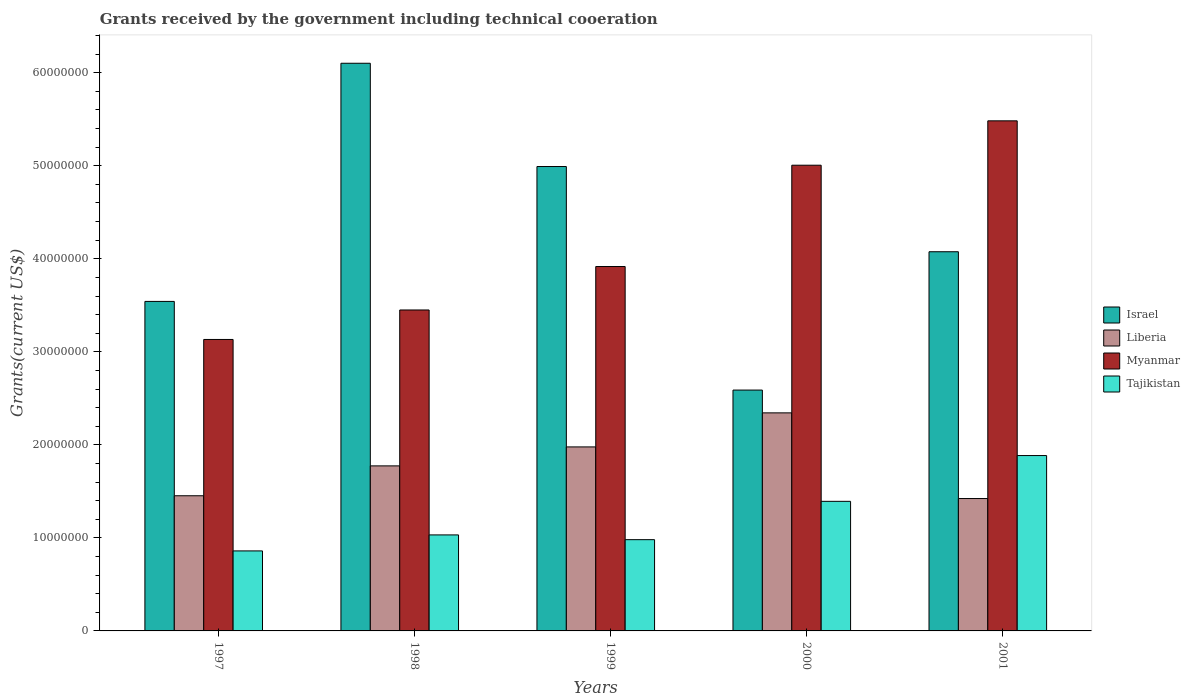How many different coloured bars are there?
Ensure brevity in your answer.  4. Are the number of bars per tick equal to the number of legend labels?
Make the answer very short. Yes. How many bars are there on the 5th tick from the left?
Offer a terse response. 4. How many bars are there on the 5th tick from the right?
Give a very brief answer. 4. In how many cases, is the number of bars for a given year not equal to the number of legend labels?
Your response must be concise. 0. What is the total grants received by the government in Israel in 1998?
Offer a very short reply. 6.10e+07. Across all years, what is the maximum total grants received by the government in Israel?
Make the answer very short. 6.10e+07. Across all years, what is the minimum total grants received by the government in Tajikistan?
Provide a short and direct response. 8.60e+06. In which year was the total grants received by the government in Israel minimum?
Your response must be concise. 2000. What is the total total grants received by the government in Myanmar in the graph?
Give a very brief answer. 2.10e+08. What is the difference between the total grants received by the government in Israel in 1997 and that in 1998?
Offer a terse response. -2.56e+07. What is the difference between the total grants received by the government in Myanmar in 1997 and the total grants received by the government in Tajikistan in 2001?
Your answer should be very brief. 1.25e+07. What is the average total grants received by the government in Israel per year?
Ensure brevity in your answer.  4.26e+07. In the year 1997, what is the difference between the total grants received by the government in Tajikistan and total grants received by the government in Myanmar?
Your answer should be very brief. -2.27e+07. In how many years, is the total grants received by the government in Myanmar greater than 26000000 US$?
Offer a terse response. 5. What is the ratio of the total grants received by the government in Myanmar in 1997 to that in 2001?
Provide a succinct answer. 0.57. Is the total grants received by the government in Myanmar in 1997 less than that in 1999?
Keep it short and to the point. Yes. Is the difference between the total grants received by the government in Tajikistan in 1999 and 2001 greater than the difference between the total grants received by the government in Myanmar in 1999 and 2001?
Offer a very short reply. Yes. What is the difference between the highest and the second highest total grants received by the government in Myanmar?
Provide a short and direct response. 4.77e+06. What is the difference between the highest and the lowest total grants received by the government in Liberia?
Provide a short and direct response. 9.21e+06. Is it the case that in every year, the sum of the total grants received by the government in Myanmar and total grants received by the government in Liberia is greater than the sum of total grants received by the government in Tajikistan and total grants received by the government in Israel?
Keep it short and to the point. No. What does the 1st bar from the left in 1997 represents?
Provide a short and direct response. Israel. What does the 2nd bar from the right in 1999 represents?
Offer a terse response. Myanmar. Is it the case that in every year, the sum of the total grants received by the government in Tajikistan and total grants received by the government in Myanmar is greater than the total grants received by the government in Israel?
Ensure brevity in your answer.  No. How many bars are there?
Make the answer very short. 20. Are all the bars in the graph horizontal?
Provide a short and direct response. No. How many years are there in the graph?
Offer a very short reply. 5. What is the difference between two consecutive major ticks on the Y-axis?
Give a very brief answer. 1.00e+07. Does the graph contain any zero values?
Offer a very short reply. No. Where does the legend appear in the graph?
Your answer should be very brief. Center right. How are the legend labels stacked?
Offer a very short reply. Vertical. What is the title of the graph?
Offer a terse response. Grants received by the government including technical cooeration. What is the label or title of the Y-axis?
Your answer should be compact. Grants(current US$). What is the Grants(current US$) of Israel in 1997?
Ensure brevity in your answer.  3.54e+07. What is the Grants(current US$) in Liberia in 1997?
Provide a succinct answer. 1.45e+07. What is the Grants(current US$) in Myanmar in 1997?
Provide a succinct answer. 3.13e+07. What is the Grants(current US$) in Tajikistan in 1997?
Give a very brief answer. 8.60e+06. What is the Grants(current US$) in Israel in 1998?
Offer a terse response. 6.10e+07. What is the Grants(current US$) in Liberia in 1998?
Give a very brief answer. 1.77e+07. What is the Grants(current US$) in Myanmar in 1998?
Ensure brevity in your answer.  3.45e+07. What is the Grants(current US$) of Tajikistan in 1998?
Your answer should be compact. 1.03e+07. What is the Grants(current US$) of Israel in 1999?
Your answer should be very brief. 4.99e+07. What is the Grants(current US$) in Liberia in 1999?
Your answer should be compact. 1.98e+07. What is the Grants(current US$) of Myanmar in 1999?
Offer a very short reply. 3.92e+07. What is the Grants(current US$) in Tajikistan in 1999?
Provide a succinct answer. 9.81e+06. What is the Grants(current US$) in Israel in 2000?
Provide a short and direct response. 2.59e+07. What is the Grants(current US$) of Liberia in 2000?
Offer a terse response. 2.34e+07. What is the Grants(current US$) of Myanmar in 2000?
Ensure brevity in your answer.  5.01e+07. What is the Grants(current US$) in Tajikistan in 2000?
Your answer should be very brief. 1.39e+07. What is the Grants(current US$) of Israel in 2001?
Keep it short and to the point. 4.08e+07. What is the Grants(current US$) of Liberia in 2001?
Your response must be concise. 1.42e+07. What is the Grants(current US$) in Myanmar in 2001?
Make the answer very short. 5.48e+07. What is the Grants(current US$) in Tajikistan in 2001?
Make the answer very short. 1.88e+07. Across all years, what is the maximum Grants(current US$) of Israel?
Your answer should be very brief. 6.10e+07. Across all years, what is the maximum Grants(current US$) in Liberia?
Offer a very short reply. 2.34e+07. Across all years, what is the maximum Grants(current US$) in Myanmar?
Make the answer very short. 5.48e+07. Across all years, what is the maximum Grants(current US$) in Tajikistan?
Offer a terse response. 1.88e+07. Across all years, what is the minimum Grants(current US$) of Israel?
Give a very brief answer. 2.59e+07. Across all years, what is the minimum Grants(current US$) of Liberia?
Offer a terse response. 1.42e+07. Across all years, what is the minimum Grants(current US$) in Myanmar?
Give a very brief answer. 3.13e+07. Across all years, what is the minimum Grants(current US$) of Tajikistan?
Provide a succinct answer. 8.60e+06. What is the total Grants(current US$) of Israel in the graph?
Keep it short and to the point. 2.13e+08. What is the total Grants(current US$) in Liberia in the graph?
Offer a terse response. 8.97e+07. What is the total Grants(current US$) of Myanmar in the graph?
Your answer should be very brief. 2.10e+08. What is the total Grants(current US$) of Tajikistan in the graph?
Provide a succinct answer. 6.15e+07. What is the difference between the Grants(current US$) in Israel in 1997 and that in 1998?
Offer a very short reply. -2.56e+07. What is the difference between the Grants(current US$) in Liberia in 1997 and that in 1998?
Keep it short and to the point. -3.21e+06. What is the difference between the Grants(current US$) in Myanmar in 1997 and that in 1998?
Make the answer very short. -3.17e+06. What is the difference between the Grants(current US$) in Tajikistan in 1997 and that in 1998?
Offer a very short reply. -1.72e+06. What is the difference between the Grants(current US$) of Israel in 1997 and that in 1999?
Your answer should be compact. -1.45e+07. What is the difference between the Grants(current US$) in Liberia in 1997 and that in 1999?
Your answer should be compact. -5.25e+06. What is the difference between the Grants(current US$) of Myanmar in 1997 and that in 1999?
Your answer should be compact. -7.84e+06. What is the difference between the Grants(current US$) of Tajikistan in 1997 and that in 1999?
Offer a terse response. -1.21e+06. What is the difference between the Grants(current US$) in Israel in 1997 and that in 2000?
Your response must be concise. 9.53e+06. What is the difference between the Grants(current US$) of Liberia in 1997 and that in 2000?
Ensure brevity in your answer.  -8.91e+06. What is the difference between the Grants(current US$) of Myanmar in 1997 and that in 2000?
Provide a short and direct response. -1.87e+07. What is the difference between the Grants(current US$) of Tajikistan in 1997 and that in 2000?
Provide a short and direct response. -5.33e+06. What is the difference between the Grants(current US$) in Israel in 1997 and that in 2001?
Your answer should be very brief. -5.34e+06. What is the difference between the Grants(current US$) in Myanmar in 1997 and that in 2001?
Offer a terse response. -2.35e+07. What is the difference between the Grants(current US$) of Tajikistan in 1997 and that in 2001?
Give a very brief answer. -1.02e+07. What is the difference between the Grants(current US$) of Israel in 1998 and that in 1999?
Provide a short and direct response. 1.11e+07. What is the difference between the Grants(current US$) in Liberia in 1998 and that in 1999?
Your answer should be compact. -2.04e+06. What is the difference between the Grants(current US$) of Myanmar in 1998 and that in 1999?
Provide a short and direct response. -4.67e+06. What is the difference between the Grants(current US$) in Tajikistan in 1998 and that in 1999?
Give a very brief answer. 5.10e+05. What is the difference between the Grants(current US$) of Israel in 1998 and that in 2000?
Give a very brief answer. 3.51e+07. What is the difference between the Grants(current US$) in Liberia in 1998 and that in 2000?
Provide a succinct answer. -5.70e+06. What is the difference between the Grants(current US$) of Myanmar in 1998 and that in 2000?
Give a very brief answer. -1.56e+07. What is the difference between the Grants(current US$) of Tajikistan in 1998 and that in 2000?
Ensure brevity in your answer.  -3.61e+06. What is the difference between the Grants(current US$) of Israel in 1998 and that in 2001?
Provide a short and direct response. 2.03e+07. What is the difference between the Grants(current US$) in Liberia in 1998 and that in 2001?
Provide a short and direct response. 3.51e+06. What is the difference between the Grants(current US$) of Myanmar in 1998 and that in 2001?
Keep it short and to the point. -2.03e+07. What is the difference between the Grants(current US$) in Tajikistan in 1998 and that in 2001?
Your answer should be compact. -8.53e+06. What is the difference between the Grants(current US$) in Israel in 1999 and that in 2000?
Keep it short and to the point. 2.40e+07. What is the difference between the Grants(current US$) of Liberia in 1999 and that in 2000?
Your answer should be compact. -3.66e+06. What is the difference between the Grants(current US$) of Myanmar in 1999 and that in 2000?
Keep it short and to the point. -1.09e+07. What is the difference between the Grants(current US$) of Tajikistan in 1999 and that in 2000?
Ensure brevity in your answer.  -4.12e+06. What is the difference between the Grants(current US$) of Israel in 1999 and that in 2001?
Provide a short and direct response. 9.16e+06. What is the difference between the Grants(current US$) in Liberia in 1999 and that in 2001?
Offer a very short reply. 5.55e+06. What is the difference between the Grants(current US$) of Myanmar in 1999 and that in 2001?
Offer a terse response. -1.57e+07. What is the difference between the Grants(current US$) of Tajikistan in 1999 and that in 2001?
Make the answer very short. -9.04e+06. What is the difference between the Grants(current US$) in Israel in 2000 and that in 2001?
Make the answer very short. -1.49e+07. What is the difference between the Grants(current US$) of Liberia in 2000 and that in 2001?
Your response must be concise. 9.21e+06. What is the difference between the Grants(current US$) in Myanmar in 2000 and that in 2001?
Ensure brevity in your answer.  -4.77e+06. What is the difference between the Grants(current US$) of Tajikistan in 2000 and that in 2001?
Give a very brief answer. -4.92e+06. What is the difference between the Grants(current US$) in Israel in 1997 and the Grants(current US$) in Liberia in 1998?
Provide a short and direct response. 1.77e+07. What is the difference between the Grants(current US$) in Israel in 1997 and the Grants(current US$) in Myanmar in 1998?
Give a very brief answer. 9.20e+05. What is the difference between the Grants(current US$) in Israel in 1997 and the Grants(current US$) in Tajikistan in 1998?
Keep it short and to the point. 2.51e+07. What is the difference between the Grants(current US$) in Liberia in 1997 and the Grants(current US$) in Myanmar in 1998?
Your answer should be very brief. -2.00e+07. What is the difference between the Grants(current US$) of Liberia in 1997 and the Grants(current US$) of Tajikistan in 1998?
Give a very brief answer. 4.21e+06. What is the difference between the Grants(current US$) of Myanmar in 1997 and the Grants(current US$) of Tajikistan in 1998?
Provide a succinct answer. 2.10e+07. What is the difference between the Grants(current US$) of Israel in 1997 and the Grants(current US$) of Liberia in 1999?
Provide a succinct answer. 1.56e+07. What is the difference between the Grants(current US$) in Israel in 1997 and the Grants(current US$) in Myanmar in 1999?
Your answer should be very brief. -3.75e+06. What is the difference between the Grants(current US$) of Israel in 1997 and the Grants(current US$) of Tajikistan in 1999?
Give a very brief answer. 2.56e+07. What is the difference between the Grants(current US$) in Liberia in 1997 and the Grants(current US$) in Myanmar in 1999?
Offer a terse response. -2.46e+07. What is the difference between the Grants(current US$) of Liberia in 1997 and the Grants(current US$) of Tajikistan in 1999?
Your response must be concise. 4.72e+06. What is the difference between the Grants(current US$) of Myanmar in 1997 and the Grants(current US$) of Tajikistan in 1999?
Offer a terse response. 2.15e+07. What is the difference between the Grants(current US$) in Israel in 1997 and the Grants(current US$) in Liberia in 2000?
Your response must be concise. 1.20e+07. What is the difference between the Grants(current US$) in Israel in 1997 and the Grants(current US$) in Myanmar in 2000?
Keep it short and to the point. -1.46e+07. What is the difference between the Grants(current US$) in Israel in 1997 and the Grants(current US$) in Tajikistan in 2000?
Offer a very short reply. 2.15e+07. What is the difference between the Grants(current US$) of Liberia in 1997 and the Grants(current US$) of Myanmar in 2000?
Your answer should be very brief. -3.55e+07. What is the difference between the Grants(current US$) in Liberia in 1997 and the Grants(current US$) in Tajikistan in 2000?
Provide a succinct answer. 6.00e+05. What is the difference between the Grants(current US$) of Myanmar in 1997 and the Grants(current US$) of Tajikistan in 2000?
Your answer should be compact. 1.74e+07. What is the difference between the Grants(current US$) in Israel in 1997 and the Grants(current US$) in Liberia in 2001?
Your response must be concise. 2.12e+07. What is the difference between the Grants(current US$) of Israel in 1997 and the Grants(current US$) of Myanmar in 2001?
Ensure brevity in your answer.  -1.94e+07. What is the difference between the Grants(current US$) in Israel in 1997 and the Grants(current US$) in Tajikistan in 2001?
Your response must be concise. 1.66e+07. What is the difference between the Grants(current US$) in Liberia in 1997 and the Grants(current US$) in Myanmar in 2001?
Offer a terse response. -4.03e+07. What is the difference between the Grants(current US$) of Liberia in 1997 and the Grants(current US$) of Tajikistan in 2001?
Ensure brevity in your answer.  -4.32e+06. What is the difference between the Grants(current US$) in Myanmar in 1997 and the Grants(current US$) in Tajikistan in 2001?
Your answer should be very brief. 1.25e+07. What is the difference between the Grants(current US$) of Israel in 1998 and the Grants(current US$) of Liberia in 1999?
Your response must be concise. 4.12e+07. What is the difference between the Grants(current US$) of Israel in 1998 and the Grants(current US$) of Myanmar in 1999?
Give a very brief answer. 2.18e+07. What is the difference between the Grants(current US$) of Israel in 1998 and the Grants(current US$) of Tajikistan in 1999?
Provide a short and direct response. 5.12e+07. What is the difference between the Grants(current US$) of Liberia in 1998 and the Grants(current US$) of Myanmar in 1999?
Provide a short and direct response. -2.14e+07. What is the difference between the Grants(current US$) of Liberia in 1998 and the Grants(current US$) of Tajikistan in 1999?
Your answer should be very brief. 7.93e+06. What is the difference between the Grants(current US$) of Myanmar in 1998 and the Grants(current US$) of Tajikistan in 1999?
Offer a terse response. 2.47e+07. What is the difference between the Grants(current US$) of Israel in 1998 and the Grants(current US$) of Liberia in 2000?
Provide a succinct answer. 3.76e+07. What is the difference between the Grants(current US$) in Israel in 1998 and the Grants(current US$) in Myanmar in 2000?
Your answer should be very brief. 1.10e+07. What is the difference between the Grants(current US$) of Israel in 1998 and the Grants(current US$) of Tajikistan in 2000?
Your answer should be very brief. 4.71e+07. What is the difference between the Grants(current US$) of Liberia in 1998 and the Grants(current US$) of Myanmar in 2000?
Your response must be concise. -3.23e+07. What is the difference between the Grants(current US$) of Liberia in 1998 and the Grants(current US$) of Tajikistan in 2000?
Ensure brevity in your answer.  3.81e+06. What is the difference between the Grants(current US$) of Myanmar in 1998 and the Grants(current US$) of Tajikistan in 2000?
Your response must be concise. 2.06e+07. What is the difference between the Grants(current US$) in Israel in 1998 and the Grants(current US$) in Liberia in 2001?
Your response must be concise. 4.68e+07. What is the difference between the Grants(current US$) in Israel in 1998 and the Grants(current US$) in Myanmar in 2001?
Ensure brevity in your answer.  6.19e+06. What is the difference between the Grants(current US$) in Israel in 1998 and the Grants(current US$) in Tajikistan in 2001?
Keep it short and to the point. 4.22e+07. What is the difference between the Grants(current US$) in Liberia in 1998 and the Grants(current US$) in Myanmar in 2001?
Offer a very short reply. -3.71e+07. What is the difference between the Grants(current US$) of Liberia in 1998 and the Grants(current US$) of Tajikistan in 2001?
Give a very brief answer. -1.11e+06. What is the difference between the Grants(current US$) of Myanmar in 1998 and the Grants(current US$) of Tajikistan in 2001?
Ensure brevity in your answer.  1.56e+07. What is the difference between the Grants(current US$) of Israel in 1999 and the Grants(current US$) of Liberia in 2000?
Offer a very short reply. 2.65e+07. What is the difference between the Grants(current US$) in Israel in 1999 and the Grants(current US$) in Myanmar in 2000?
Provide a short and direct response. -1.40e+05. What is the difference between the Grants(current US$) in Israel in 1999 and the Grants(current US$) in Tajikistan in 2000?
Offer a terse response. 3.60e+07. What is the difference between the Grants(current US$) in Liberia in 1999 and the Grants(current US$) in Myanmar in 2000?
Keep it short and to the point. -3.03e+07. What is the difference between the Grants(current US$) in Liberia in 1999 and the Grants(current US$) in Tajikistan in 2000?
Offer a terse response. 5.85e+06. What is the difference between the Grants(current US$) of Myanmar in 1999 and the Grants(current US$) of Tajikistan in 2000?
Give a very brief answer. 2.52e+07. What is the difference between the Grants(current US$) in Israel in 1999 and the Grants(current US$) in Liberia in 2001?
Give a very brief answer. 3.57e+07. What is the difference between the Grants(current US$) in Israel in 1999 and the Grants(current US$) in Myanmar in 2001?
Ensure brevity in your answer.  -4.91e+06. What is the difference between the Grants(current US$) in Israel in 1999 and the Grants(current US$) in Tajikistan in 2001?
Give a very brief answer. 3.11e+07. What is the difference between the Grants(current US$) in Liberia in 1999 and the Grants(current US$) in Myanmar in 2001?
Provide a succinct answer. -3.50e+07. What is the difference between the Grants(current US$) in Liberia in 1999 and the Grants(current US$) in Tajikistan in 2001?
Your answer should be very brief. 9.30e+05. What is the difference between the Grants(current US$) of Myanmar in 1999 and the Grants(current US$) of Tajikistan in 2001?
Offer a very short reply. 2.03e+07. What is the difference between the Grants(current US$) of Israel in 2000 and the Grants(current US$) of Liberia in 2001?
Give a very brief answer. 1.17e+07. What is the difference between the Grants(current US$) of Israel in 2000 and the Grants(current US$) of Myanmar in 2001?
Keep it short and to the point. -2.89e+07. What is the difference between the Grants(current US$) in Israel in 2000 and the Grants(current US$) in Tajikistan in 2001?
Give a very brief answer. 7.04e+06. What is the difference between the Grants(current US$) of Liberia in 2000 and the Grants(current US$) of Myanmar in 2001?
Offer a terse response. -3.14e+07. What is the difference between the Grants(current US$) in Liberia in 2000 and the Grants(current US$) in Tajikistan in 2001?
Offer a terse response. 4.59e+06. What is the difference between the Grants(current US$) in Myanmar in 2000 and the Grants(current US$) in Tajikistan in 2001?
Give a very brief answer. 3.12e+07. What is the average Grants(current US$) in Israel per year?
Offer a terse response. 4.26e+07. What is the average Grants(current US$) of Liberia per year?
Ensure brevity in your answer.  1.79e+07. What is the average Grants(current US$) of Myanmar per year?
Ensure brevity in your answer.  4.20e+07. What is the average Grants(current US$) of Tajikistan per year?
Your response must be concise. 1.23e+07. In the year 1997, what is the difference between the Grants(current US$) of Israel and Grants(current US$) of Liberia?
Make the answer very short. 2.09e+07. In the year 1997, what is the difference between the Grants(current US$) in Israel and Grants(current US$) in Myanmar?
Provide a succinct answer. 4.09e+06. In the year 1997, what is the difference between the Grants(current US$) of Israel and Grants(current US$) of Tajikistan?
Your answer should be compact. 2.68e+07. In the year 1997, what is the difference between the Grants(current US$) in Liberia and Grants(current US$) in Myanmar?
Offer a terse response. -1.68e+07. In the year 1997, what is the difference between the Grants(current US$) of Liberia and Grants(current US$) of Tajikistan?
Offer a very short reply. 5.93e+06. In the year 1997, what is the difference between the Grants(current US$) of Myanmar and Grants(current US$) of Tajikistan?
Ensure brevity in your answer.  2.27e+07. In the year 1998, what is the difference between the Grants(current US$) in Israel and Grants(current US$) in Liberia?
Give a very brief answer. 4.33e+07. In the year 1998, what is the difference between the Grants(current US$) of Israel and Grants(current US$) of Myanmar?
Your response must be concise. 2.65e+07. In the year 1998, what is the difference between the Grants(current US$) of Israel and Grants(current US$) of Tajikistan?
Ensure brevity in your answer.  5.07e+07. In the year 1998, what is the difference between the Grants(current US$) of Liberia and Grants(current US$) of Myanmar?
Your answer should be compact. -1.68e+07. In the year 1998, what is the difference between the Grants(current US$) of Liberia and Grants(current US$) of Tajikistan?
Your answer should be very brief. 7.42e+06. In the year 1998, what is the difference between the Grants(current US$) of Myanmar and Grants(current US$) of Tajikistan?
Give a very brief answer. 2.42e+07. In the year 1999, what is the difference between the Grants(current US$) of Israel and Grants(current US$) of Liberia?
Provide a short and direct response. 3.01e+07. In the year 1999, what is the difference between the Grants(current US$) in Israel and Grants(current US$) in Myanmar?
Your answer should be compact. 1.08e+07. In the year 1999, what is the difference between the Grants(current US$) in Israel and Grants(current US$) in Tajikistan?
Make the answer very short. 4.01e+07. In the year 1999, what is the difference between the Grants(current US$) of Liberia and Grants(current US$) of Myanmar?
Your response must be concise. -1.94e+07. In the year 1999, what is the difference between the Grants(current US$) of Liberia and Grants(current US$) of Tajikistan?
Provide a short and direct response. 9.97e+06. In the year 1999, what is the difference between the Grants(current US$) of Myanmar and Grants(current US$) of Tajikistan?
Offer a very short reply. 2.94e+07. In the year 2000, what is the difference between the Grants(current US$) in Israel and Grants(current US$) in Liberia?
Give a very brief answer. 2.45e+06. In the year 2000, what is the difference between the Grants(current US$) in Israel and Grants(current US$) in Myanmar?
Give a very brief answer. -2.42e+07. In the year 2000, what is the difference between the Grants(current US$) of Israel and Grants(current US$) of Tajikistan?
Offer a very short reply. 1.20e+07. In the year 2000, what is the difference between the Grants(current US$) in Liberia and Grants(current US$) in Myanmar?
Your response must be concise. -2.66e+07. In the year 2000, what is the difference between the Grants(current US$) of Liberia and Grants(current US$) of Tajikistan?
Provide a succinct answer. 9.51e+06. In the year 2000, what is the difference between the Grants(current US$) of Myanmar and Grants(current US$) of Tajikistan?
Make the answer very short. 3.61e+07. In the year 2001, what is the difference between the Grants(current US$) in Israel and Grants(current US$) in Liberia?
Your response must be concise. 2.65e+07. In the year 2001, what is the difference between the Grants(current US$) of Israel and Grants(current US$) of Myanmar?
Your response must be concise. -1.41e+07. In the year 2001, what is the difference between the Grants(current US$) of Israel and Grants(current US$) of Tajikistan?
Your answer should be compact. 2.19e+07. In the year 2001, what is the difference between the Grants(current US$) in Liberia and Grants(current US$) in Myanmar?
Make the answer very short. -4.06e+07. In the year 2001, what is the difference between the Grants(current US$) in Liberia and Grants(current US$) in Tajikistan?
Your response must be concise. -4.62e+06. In the year 2001, what is the difference between the Grants(current US$) of Myanmar and Grants(current US$) of Tajikistan?
Offer a terse response. 3.60e+07. What is the ratio of the Grants(current US$) in Israel in 1997 to that in 1998?
Your answer should be compact. 0.58. What is the ratio of the Grants(current US$) of Liberia in 1997 to that in 1998?
Make the answer very short. 0.82. What is the ratio of the Grants(current US$) in Myanmar in 1997 to that in 1998?
Your answer should be very brief. 0.91. What is the ratio of the Grants(current US$) of Israel in 1997 to that in 1999?
Your response must be concise. 0.71. What is the ratio of the Grants(current US$) in Liberia in 1997 to that in 1999?
Your answer should be very brief. 0.73. What is the ratio of the Grants(current US$) of Myanmar in 1997 to that in 1999?
Provide a succinct answer. 0.8. What is the ratio of the Grants(current US$) in Tajikistan in 1997 to that in 1999?
Offer a terse response. 0.88. What is the ratio of the Grants(current US$) of Israel in 1997 to that in 2000?
Ensure brevity in your answer.  1.37. What is the ratio of the Grants(current US$) in Liberia in 1997 to that in 2000?
Your answer should be compact. 0.62. What is the ratio of the Grants(current US$) of Myanmar in 1997 to that in 2000?
Ensure brevity in your answer.  0.63. What is the ratio of the Grants(current US$) in Tajikistan in 1997 to that in 2000?
Your answer should be compact. 0.62. What is the ratio of the Grants(current US$) in Israel in 1997 to that in 2001?
Your response must be concise. 0.87. What is the ratio of the Grants(current US$) of Liberia in 1997 to that in 2001?
Make the answer very short. 1.02. What is the ratio of the Grants(current US$) of Myanmar in 1997 to that in 2001?
Make the answer very short. 0.57. What is the ratio of the Grants(current US$) of Tajikistan in 1997 to that in 2001?
Keep it short and to the point. 0.46. What is the ratio of the Grants(current US$) of Israel in 1998 to that in 1999?
Offer a very short reply. 1.22. What is the ratio of the Grants(current US$) of Liberia in 1998 to that in 1999?
Keep it short and to the point. 0.9. What is the ratio of the Grants(current US$) of Myanmar in 1998 to that in 1999?
Ensure brevity in your answer.  0.88. What is the ratio of the Grants(current US$) in Tajikistan in 1998 to that in 1999?
Make the answer very short. 1.05. What is the ratio of the Grants(current US$) in Israel in 1998 to that in 2000?
Provide a succinct answer. 2.36. What is the ratio of the Grants(current US$) in Liberia in 1998 to that in 2000?
Offer a very short reply. 0.76. What is the ratio of the Grants(current US$) in Myanmar in 1998 to that in 2000?
Give a very brief answer. 0.69. What is the ratio of the Grants(current US$) in Tajikistan in 1998 to that in 2000?
Provide a succinct answer. 0.74. What is the ratio of the Grants(current US$) in Israel in 1998 to that in 2001?
Your response must be concise. 1.5. What is the ratio of the Grants(current US$) in Liberia in 1998 to that in 2001?
Offer a terse response. 1.25. What is the ratio of the Grants(current US$) in Myanmar in 1998 to that in 2001?
Your response must be concise. 0.63. What is the ratio of the Grants(current US$) of Tajikistan in 1998 to that in 2001?
Provide a succinct answer. 0.55. What is the ratio of the Grants(current US$) of Israel in 1999 to that in 2000?
Offer a very short reply. 1.93. What is the ratio of the Grants(current US$) of Liberia in 1999 to that in 2000?
Offer a very short reply. 0.84. What is the ratio of the Grants(current US$) of Myanmar in 1999 to that in 2000?
Provide a succinct answer. 0.78. What is the ratio of the Grants(current US$) in Tajikistan in 1999 to that in 2000?
Your answer should be compact. 0.7. What is the ratio of the Grants(current US$) in Israel in 1999 to that in 2001?
Keep it short and to the point. 1.22. What is the ratio of the Grants(current US$) of Liberia in 1999 to that in 2001?
Your response must be concise. 1.39. What is the ratio of the Grants(current US$) of Myanmar in 1999 to that in 2001?
Make the answer very short. 0.71. What is the ratio of the Grants(current US$) of Tajikistan in 1999 to that in 2001?
Make the answer very short. 0.52. What is the ratio of the Grants(current US$) of Israel in 2000 to that in 2001?
Offer a very short reply. 0.64. What is the ratio of the Grants(current US$) in Liberia in 2000 to that in 2001?
Your answer should be very brief. 1.65. What is the ratio of the Grants(current US$) of Myanmar in 2000 to that in 2001?
Your response must be concise. 0.91. What is the ratio of the Grants(current US$) of Tajikistan in 2000 to that in 2001?
Offer a terse response. 0.74. What is the difference between the highest and the second highest Grants(current US$) of Israel?
Give a very brief answer. 1.11e+07. What is the difference between the highest and the second highest Grants(current US$) in Liberia?
Your answer should be compact. 3.66e+06. What is the difference between the highest and the second highest Grants(current US$) in Myanmar?
Your answer should be compact. 4.77e+06. What is the difference between the highest and the second highest Grants(current US$) in Tajikistan?
Offer a very short reply. 4.92e+06. What is the difference between the highest and the lowest Grants(current US$) in Israel?
Offer a very short reply. 3.51e+07. What is the difference between the highest and the lowest Grants(current US$) of Liberia?
Keep it short and to the point. 9.21e+06. What is the difference between the highest and the lowest Grants(current US$) in Myanmar?
Give a very brief answer. 2.35e+07. What is the difference between the highest and the lowest Grants(current US$) in Tajikistan?
Your answer should be very brief. 1.02e+07. 